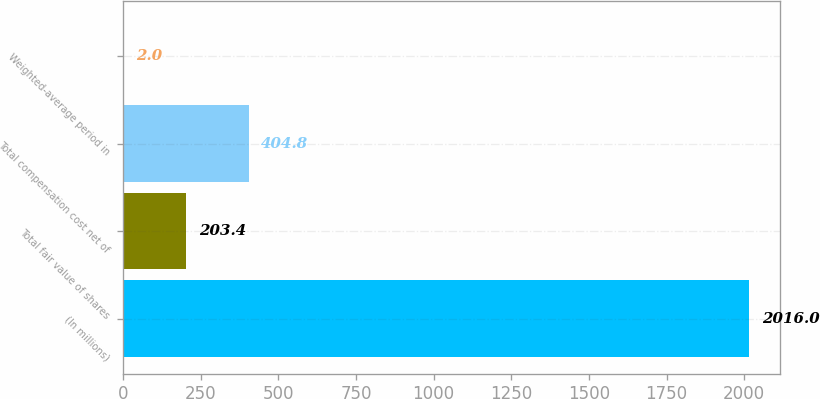Convert chart to OTSL. <chart><loc_0><loc_0><loc_500><loc_500><bar_chart><fcel>(In millions)<fcel>Total fair value of shares<fcel>Total compensation cost net of<fcel>Weighted-average period in<nl><fcel>2016<fcel>203.4<fcel>404.8<fcel>2<nl></chart> 